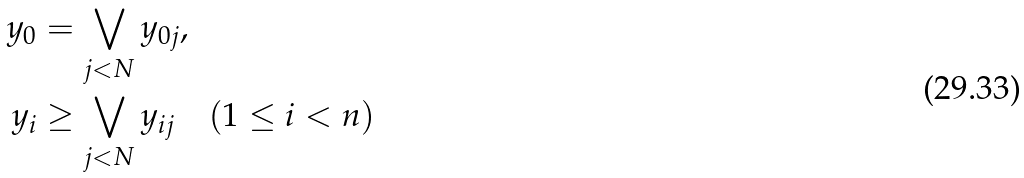Convert formula to latex. <formula><loc_0><loc_0><loc_500><loc_500>y _ { 0 } & = \bigvee _ { j < N } y _ { 0 j } , \\ y _ { i } & \geq \bigvee _ { j < N } y _ { i j } \quad ( 1 \leq i < n )</formula> 